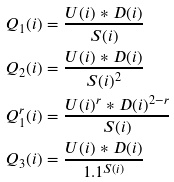<formula> <loc_0><loc_0><loc_500><loc_500>Q _ { 1 } ( i ) & = \frac { U ( i ) * D ( i ) } { S ( i ) } \\ Q _ { 2 } ( i ) & = \frac { U ( i ) * D ( i ) } { S ( i ) ^ { 2 } } \\ \quad Q _ { 1 } ^ { r } ( i ) & = \frac { U ( i ) ^ { r } * D ( i ) ^ { 2 - r } } { S ( i ) } \\ Q _ { 3 } ( i ) & = \frac { U ( i ) * D ( i ) } { 1 . 1 ^ { S ( i ) } } \\</formula> 